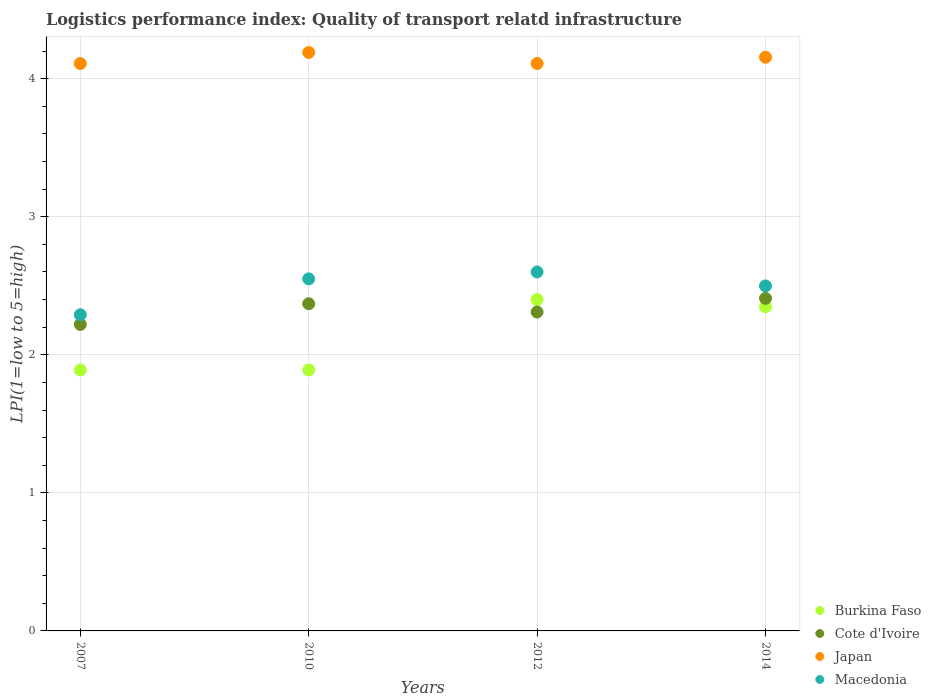How many different coloured dotlines are there?
Your answer should be compact. 4. What is the logistics performance index in Burkina Faso in 2010?
Make the answer very short. 1.89. Across all years, what is the maximum logistics performance index in Macedonia?
Provide a succinct answer. 2.6. Across all years, what is the minimum logistics performance index in Macedonia?
Your response must be concise. 2.29. What is the total logistics performance index in Macedonia in the graph?
Make the answer very short. 9.94. What is the difference between the logistics performance index in Macedonia in 2007 and that in 2014?
Your answer should be very brief. -0.21. What is the difference between the logistics performance index in Cote d'Ivoire in 2014 and the logistics performance index in Japan in 2010?
Offer a very short reply. -1.78. What is the average logistics performance index in Cote d'Ivoire per year?
Offer a terse response. 2.33. In the year 2010, what is the difference between the logistics performance index in Macedonia and logistics performance index in Burkina Faso?
Your answer should be very brief. 0.66. What is the ratio of the logistics performance index in Japan in 2007 to that in 2012?
Your answer should be compact. 1. What is the difference between the highest and the second highest logistics performance index in Macedonia?
Offer a terse response. 0.05. What is the difference between the highest and the lowest logistics performance index in Burkina Faso?
Give a very brief answer. 0.51. In how many years, is the logistics performance index in Japan greater than the average logistics performance index in Japan taken over all years?
Keep it short and to the point. 2. Does the logistics performance index in Cote d'Ivoire monotonically increase over the years?
Provide a succinct answer. No. Is the logistics performance index in Japan strictly less than the logistics performance index in Cote d'Ivoire over the years?
Your answer should be compact. No. What is the difference between two consecutive major ticks on the Y-axis?
Ensure brevity in your answer.  1. Does the graph contain grids?
Give a very brief answer. Yes. Where does the legend appear in the graph?
Offer a terse response. Bottom right. How many legend labels are there?
Offer a terse response. 4. How are the legend labels stacked?
Give a very brief answer. Vertical. What is the title of the graph?
Offer a very short reply. Logistics performance index: Quality of transport relatd infrastructure. What is the label or title of the X-axis?
Provide a short and direct response. Years. What is the label or title of the Y-axis?
Make the answer very short. LPI(1=low to 5=high). What is the LPI(1=low to 5=high) in Burkina Faso in 2007?
Offer a very short reply. 1.89. What is the LPI(1=low to 5=high) of Cote d'Ivoire in 2007?
Provide a succinct answer. 2.22. What is the LPI(1=low to 5=high) of Japan in 2007?
Keep it short and to the point. 4.11. What is the LPI(1=low to 5=high) of Macedonia in 2007?
Offer a terse response. 2.29. What is the LPI(1=low to 5=high) in Burkina Faso in 2010?
Your response must be concise. 1.89. What is the LPI(1=low to 5=high) in Cote d'Ivoire in 2010?
Provide a succinct answer. 2.37. What is the LPI(1=low to 5=high) in Japan in 2010?
Make the answer very short. 4.19. What is the LPI(1=low to 5=high) in Macedonia in 2010?
Offer a terse response. 2.55. What is the LPI(1=low to 5=high) of Burkina Faso in 2012?
Offer a terse response. 2.4. What is the LPI(1=low to 5=high) in Cote d'Ivoire in 2012?
Offer a very short reply. 2.31. What is the LPI(1=low to 5=high) in Japan in 2012?
Provide a short and direct response. 4.11. What is the LPI(1=low to 5=high) in Macedonia in 2012?
Your response must be concise. 2.6. What is the LPI(1=low to 5=high) in Burkina Faso in 2014?
Make the answer very short. 2.35. What is the LPI(1=low to 5=high) of Cote d'Ivoire in 2014?
Your response must be concise. 2.41. What is the LPI(1=low to 5=high) in Japan in 2014?
Your response must be concise. 4.16. What is the LPI(1=low to 5=high) of Macedonia in 2014?
Your response must be concise. 2.5. Across all years, what is the maximum LPI(1=low to 5=high) in Cote d'Ivoire?
Your response must be concise. 2.41. Across all years, what is the maximum LPI(1=low to 5=high) in Japan?
Ensure brevity in your answer.  4.19. Across all years, what is the maximum LPI(1=low to 5=high) in Macedonia?
Provide a short and direct response. 2.6. Across all years, what is the minimum LPI(1=low to 5=high) in Burkina Faso?
Give a very brief answer. 1.89. Across all years, what is the minimum LPI(1=low to 5=high) of Cote d'Ivoire?
Your answer should be very brief. 2.22. Across all years, what is the minimum LPI(1=low to 5=high) of Japan?
Provide a succinct answer. 4.11. Across all years, what is the minimum LPI(1=low to 5=high) of Macedonia?
Ensure brevity in your answer.  2.29. What is the total LPI(1=low to 5=high) in Burkina Faso in the graph?
Offer a terse response. 8.53. What is the total LPI(1=low to 5=high) of Cote d'Ivoire in the graph?
Give a very brief answer. 9.31. What is the total LPI(1=low to 5=high) of Japan in the graph?
Keep it short and to the point. 16.57. What is the total LPI(1=low to 5=high) in Macedonia in the graph?
Give a very brief answer. 9.94. What is the difference between the LPI(1=low to 5=high) in Burkina Faso in 2007 and that in 2010?
Keep it short and to the point. 0. What is the difference between the LPI(1=low to 5=high) in Cote d'Ivoire in 2007 and that in 2010?
Provide a short and direct response. -0.15. What is the difference between the LPI(1=low to 5=high) of Japan in 2007 and that in 2010?
Offer a very short reply. -0.08. What is the difference between the LPI(1=low to 5=high) of Macedonia in 2007 and that in 2010?
Provide a short and direct response. -0.26. What is the difference between the LPI(1=low to 5=high) of Burkina Faso in 2007 and that in 2012?
Keep it short and to the point. -0.51. What is the difference between the LPI(1=low to 5=high) of Cote d'Ivoire in 2007 and that in 2012?
Your response must be concise. -0.09. What is the difference between the LPI(1=low to 5=high) of Japan in 2007 and that in 2012?
Offer a very short reply. 0. What is the difference between the LPI(1=low to 5=high) in Macedonia in 2007 and that in 2012?
Provide a short and direct response. -0.31. What is the difference between the LPI(1=low to 5=high) of Burkina Faso in 2007 and that in 2014?
Your answer should be compact. -0.46. What is the difference between the LPI(1=low to 5=high) in Cote d'Ivoire in 2007 and that in 2014?
Provide a short and direct response. -0.19. What is the difference between the LPI(1=low to 5=high) of Japan in 2007 and that in 2014?
Provide a short and direct response. -0.05. What is the difference between the LPI(1=low to 5=high) of Macedonia in 2007 and that in 2014?
Your answer should be very brief. -0.21. What is the difference between the LPI(1=low to 5=high) in Burkina Faso in 2010 and that in 2012?
Ensure brevity in your answer.  -0.51. What is the difference between the LPI(1=low to 5=high) in Japan in 2010 and that in 2012?
Ensure brevity in your answer.  0.08. What is the difference between the LPI(1=low to 5=high) of Burkina Faso in 2010 and that in 2014?
Offer a terse response. -0.46. What is the difference between the LPI(1=low to 5=high) of Cote d'Ivoire in 2010 and that in 2014?
Offer a terse response. -0.04. What is the difference between the LPI(1=low to 5=high) in Japan in 2010 and that in 2014?
Your answer should be compact. 0.03. What is the difference between the LPI(1=low to 5=high) in Macedonia in 2010 and that in 2014?
Make the answer very short. 0.05. What is the difference between the LPI(1=low to 5=high) in Burkina Faso in 2012 and that in 2014?
Your answer should be very brief. 0.05. What is the difference between the LPI(1=low to 5=high) of Cote d'Ivoire in 2012 and that in 2014?
Give a very brief answer. -0.1. What is the difference between the LPI(1=low to 5=high) in Japan in 2012 and that in 2014?
Provide a short and direct response. -0.05. What is the difference between the LPI(1=low to 5=high) in Macedonia in 2012 and that in 2014?
Provide a short and direct response. 0.1. What is the difference between the LPI(1=low to 5=high) in Burkina Faso in 2007 and the LPI(1=low to 5=high) in Cote d'Ivoire in 2010?
Your answer should be very brief. -0.48. What is the difference between the LPI(1=low to 5=high) of Burkina Faso in 2007 and the LPI(1=low to 5=high) of Macedonia in 2010?
Your answer should be compact. -0.66. What is the difference between the LPI(1=low to 5=high) in Cote d'Ivoire in 2007 and the LPI(1=low to 5=high) in Japan in 2010?
Keep it short and to the point. -1.97. What is the difference between the LPI(1=low to 5=high) in Cote d'Ivoire in 2007 and the LPI(1=low to 5=high) in Macedonia in 2010?
Offer a terse response. -0.33. What is the difference between the LPI(1=low to 5=high) of Japan in 2007 and the LPI(1=low to 5=high) of Macedonia in 2010?
Provide a short and direct response. 1.56. What is the difference between the LPI(1=low to 5=high) in Burkina Faso in 2007 and the LPI(1=low to 5=high) in Cote d'Ivoire in 2012?
Keep it short and to the point. -0.42. What is the difference between the LPI(1=low to 5=high) of Burkina Faso in 2007 and the LPI(1=low to 5=high) of Japan in 2012?
Your answer should be compact. -2.22. What is the difference between the LPI(1=low to 5=high) of Burkina Faso in 2007 and the LPI(1=low to 5=high) of Macedonia in 2012?
Your answer should be compact. -0.71. What is the difference between the LPI(1=low to 5=high) of Cote d'Ivoire in 2007 and the LPI(1=low to 5=high) of Japan in 2012?
Keep it short and to the point. -1.89. What is the difference between the LPI(1=low to 5=high) of Cote d'Ivoire in 2007 and the LPI(1=low to 5=high) of Macedonia in 2012?
Your answer should be compact. -0.38. What is the difference between the LPI(1=low to 5=high) of Japan in 2007 and the LPI(1=low to 5=high) of Macedonia in 2012?
Give a very brief answer. 1.51. What is the difference between the LPI(1=low to 5=high) in Burkina Faso in 2007 and the LPI(1=low to 5=high) in Cote d'Ivoire in 2014?
Your response must be concise. -0.52. What is the difference between the LPI(1=low to 5=high) of Burkina Faso in 2007 and the LPI(1=low to 5=high) of Japan in 2014?
Give a very brief answer. -2.27. What is the difference between the LPI(1=low to 5=high) of Burkina Faso in 2007 and the LPI(1=low to 5=high) of Macedonia in 2014?
Your response must be concise. -0.61. What is the difference between the LPI(1=low to 5=high) of Cote d'Ivoire in 2007 and the LPI(1=low to 5=high) of Japan in 2014?
Your response must be concise. -1.94. What is the difference between the LPI(1=low to 5=high) in Cote d'Ivoire in 2007 and the LPI(1=low to 5=high) in Macedonia in 2014?
Your response must be concise. -0.28. What is the difference between the LPI(1=low to 5=high) in Japan in 2007 and the LPI(1=low to 5=high) in Macedonia in 2014?
Provide a succinct answer. 1.61. What is the difference between the LPI(1=low to 5=high) in Burkina Faso in 2010 and the LPI(1=low to 5=high) in Cote d'Ivoire in 2012?
Offer a terse response. -0.42. What is the difference between the LPI(1=low to 5=high) in Burkina Faso in 2010 and the LPI(1=low to 5=high) in Japan in 2012?
Offer a very short reply. -2.22. What is the difference between the LPI(1=low to 5=high) of Burkina Faso in 2010 and the LPI(1=low to 5=high) of Macedonia in 2012?
Give a very brief answer. -0.71. What is the difference between the LPI(1=low to 5=high) of Cote d'Ivoire in 2010 and the LPI(1=low to 5=high) of Japan in 2012?
Give a very brief answer. -1.74. What is the difference between the LPI(1=low to 5=high) of Cote d'Ivoire in 2010 and the LPI(1=low to 5=high) of Macedonia in 2012?
Provide a succinct answer. -0.23. What is the difference between the LPI(1=low to 5=high) of Japan in 2010 and the LPI(1=low to 5=high) of Macedonia in 2012?
Keep it short and to the point. 1.59. What is the difference between the LPI(1=low to 5=high) in Burkina Faso in 2010 and the LPI(1=low to 5=high) in Cote d'Ivoire in 2014?
Ensure brevity in your answer.  -0.52. What is the difference between the LPI(1=low to 5=high) in Burkina Faso in 2010 and the LPI(1=low to 5=high) in Japan in 2014?
Give a very brief answer. -2.27. What is the difference between the LPI(1=low to 5=high) in Burkina Faso in 2010 and the LPI(1=low to 5=high) in Macedonia in 2014?
Offer a very short reply. -0.61. What is the difference between the LPI(1=low to 5=high) in Cote d'Ivoire in 2010 and the LPI(1=low to 5=high) in Japan in 2014?
Provide a short and direct response. -1.79. What is the difference between the LPI(1=low to 5=high) in Cote d'Ivoire in 2010 and the LPI(1=low to 5=high) in Macedonia in 2014?
Provide a succinct answer. -0.13. What is the difference between the LPI(1=low to 5=high) of Japan in 2010 and the LPI(1=low to 5=high) of Macedonia in 2014?
Provide a short and direct response. 1.69. What is the difference between the LPI(1=low to 5=high) of Burkina Faso in 2012 and the LPI(1=low to 5=high) of Cote d'Ivoire in 2014?
Your answer should be compact. -0.01. What is the difference between the LPI(1=low to 5=high) in Burkina Faso in 2012 and the LPI(1=low to 5=high) in Japan in 2014?
Your answer should be compact. -1.76. What is the difference between the LPI(1=low to 5=high) in Burkina Faso in 2012 and the LPI(1=low to 5=high) in Macedonia in 2014?
Your response must be concise. -0.1. What is the difference between the LPI(1=low to 5=high) of Cote d'Ivoire in 2012 and the LPI(1=low to 5=high) of Japan in 2014?
Provide a short and direct response. -1.85. What is the difference between the LPI(1=low to 5=high) of Cote d'Ivoire in 2012 and the LPI(1=low to 5=high) of Macedonia in 2014?
Offer a very short reply. -0.19. What is the difference between the LPI(1=low to 5=high) in Japan in 2012 and the LPI(1=low to 5=high) in Macedonia in 2014?
Give a very brief answer. 1.61. What is the average LPI(1=low to 5=high) of Burkina Faso per year?
Your response must be concise. 2.13. What is the average LPI(1=low to 5=high) of Cote d'Ivoire per year?
Keep it short and to the point. 2.33. What is the average LPI(1=low to 5=high) of Japan per year?
Offer a very short reply. 4.14. What is the average LPI(1=low to 5=high) in Macedonia per year?
Ensure brevity in your answer.  2.48. In the year 2007, what is the difference between the LPI(1=low to 5=high) in Burkina Faso and LPI(1=low to 5=high) in Cote d'Ivoire?
Your answer should be compact. -0.33. In the year 2007, what is the difference between the LPI(1=low to 5=high) of Burkina Faso and LPI(1=low to 5=high) of Japan?
Make the answer very short. -2.22. In the year 2007, what is the difference between the LPI(1=low to 5=high) of Burkina Faso and LPI(1=low to 5=high) of Macedonia?
Offer a terse response. -0.4. In the year 2007, what is the difference between the LPI(1=low to 5=high) in Cote d'Ivoire and LPI(1=low to 5=high) in Japan?
Offer a very short reply. -1.89. In the year 2007, what is the difference between the LPI(1=low to 5=high) in Cote d'Ivoire and LPI(1=low to 5=high) in Macedonia?
Your answer should be compact. -0.07. In the year 2007, what is the difference between the LPI(1=low to 5=high) of Japan and LPI(1=low to 5=high) of Macedonia?
Offer a very short reply. 1.82. In the year 2010, what is the difference between the LPI(1=low to 5=high) in Burkina Faso and LPI(1=low to 5=high) in Cote d'Ivoire?
Your answer should be very brief. -0.48. In the year 2010, what is the difference between the LPI(1=low to 5=high) of Burkina Faso and LPI(1=low to 5=high) of Japan?
Give a very brief answer. -2.3. In the year 2010, what is the difference between the LPI(1=low to 5=high) in Burkina Faso and LPI(1=low to 5=high) in Macedonia?
Offer a very short reply. -0.66. In the year 2010, what is the difference between the LPI(1=low to 5=high) of Cote d'Ivoire and LPI(1=low to 5=high) of Japan?
Give a very brief answer. -1.82. In the year 2010, what is the difference between the LPI(1=low to 5=high) of Cote d'Ivoire and LPI(1=low to 5=high) of Macedonia?
Provide a short and direct response. -0.18. In the year 2010, what is the difference between the LPI(1=low to 5=high) in Japan and LPI(1=low to 5=high) in Macedonia?
Your response must be concise. 1.64. In the year 2012, what is the difference between the LPI(1=low to 5=high) in Burkina Faso and LPI(1=low to 5=high) in Cote d'Ivoire?
Offer a terse response. 0.09. In the year 2012, what is the difference between the LPI(1=low to 5=high) of Burkina Faso and LPI(1=low to 5=high) of Japan?
Ensure brevity in your answer.  -1.71. In the year 2012, what is the difference between the LPI(1=low to 5=high) of Burkina Faso and LPI(1=low to 5=high) of Macedonia?
Make the answer very short. -0.2. In the year 2012, what is the difference between the LPI(1=low to 5=high) of Cote d'Ivoire and LPI(1=low to 5=high) of Japan?
Provide a succinct answer. -1.8. In the year 2012, what is the difference between the LPI(1=low to 5=high) of Cote d'Ivoire and LPI(1=low to 5=high) of Macedonia?
Give a very brief answer. -0.29. In the year 2012, what is the difference between the LPI(1=low to 5=high) of Japan and LPI(1=low to 5=high) of Macedonia?
Your answer should be compact. 1.51. In the year 2014, what is the difference between the LPI(1=low to 5=high) in Burkina Faso and LPI(1=low to 5=high) in Cote d'Ivoire?
Your response must be concise. -0.06. In the year 2014, what is the difference between the LPI(1=low to 5=high) of Burkina Faso and LPI(1=low to 5=high) of Japan?
Provide a succinct answer. -1.81. In the year 2014, what is the difference between the LPI(1=low to 5=high) of Burkina Faso and LPI(1=low to 5=high) of Macedonia?
Offer a terse response. -0.15. In the year 2014, what is the difference between the LPI(1=low to 5=high) of Cote d'Ivoire and LPI(1=low to 5=high) of Japan?
Offer a terse response. -1.75. In the year 2014, what is the difference between the LPI(1=low to 5=high) of Cote d'Ivoire and LPI(1=low to 5=high) of Macedonia?
Your answer should be compact. -0.09. In the year 2014, what is the difference between the LPI(1=low to 5=high) of Japan and LPI(1=low to 5=high) of Macedonia?
Your answer should be very brief. 1.66. What is the ratio of the LPI(1=low to 5=high) of Cote d'Ivoire in 2007 to that in 2010?
Your answer should be very brief. 0.94. What is the ratio of the LPI(1=low to 5=high) of Japan in 2007 to that in 2010?
Offer a very short reply. 0.98. What is the ratio of the LPI(1=low to 5=high) of Macedonia in 2007 to that in 2010?
Make the answer very short. 0.9. What is the ratio of the LPI(1=low to 5=high) of Burkina Faso in 2007 to that in 2012?
Provide a succinct answer. 0.79. What is the ratio of the LPI(1=low to 5=high) of Japan in 2007 to that in 2012?
Keep it short and to the point. 1. What is the ratio of the LPI(1=low to 5=high) in Macedonia in 2007 to that in 2012?
Give a very brief answer. 0.88. What is the ratio of the LPI(1=low to 5=high) of Burkina Faso in 2007 to that in 2014?
Offer a very short reply. 0.8. What is the ratio of the LPI(1=low to 5=high) of Cote d'Ivoire in 2007 to that in 2014?
Your answer should be compact. 0.92. What is the ratio of the LPI(1=low to 5=high) of Japan in 2007 to that in 2014?
Your answer should be very brief. 0.99. What is the ratio of the LPI(1=low to 5=high) of Macedonia in 2007 to that in 2014?
Provide a succinct answer. 0.92. What is the ratio of the LPI(1=low to 5=high) in Burkina Faso in 2010 to that in 2012?
Your answer should be compact. 0.79. What is the ratio of the LPI(1=low to 5=high) in Japan in 2010 to that in 2012?
Give a very brief answer. 1.02. What is the ratio of the LPI(1=low to 5=high) in Macedonia in 2010 to that in 2012?
Offer a terse response. 0.98. What is the ratio of the LPI(1=low to 5=high) in Burkina Faso in 2010 to that in 2014?
Provide a succinct answer. 0.8. What is the ratio of the LPI(1=low to 5=high) in Cote d'Ivoire in 2010 to that in 2014?
Provide a short and direct response. 0.98. What is the ratio of the LPI(1=low to 5=high) in Japan in 2010 to that in 2014?
Your response must be concise. 1.01. What is the ratio of the LPI(1=low to 5=high) of Macedonia in 2010 to that in 2014?
Your answer should be very brief. 1.02. What is the ratio of the LPI(1=low to 5=high) in Burkina Faso in 2012 to that in 2014?
Offer a terse response. 1.02. What is the ratio of the LPI(1=low to 5=high) in Macedonia in 2012 to that in 2014?
Make the answer very short. 1.04. What is the difference between the highest and the second highest LPI(1=low to 5=high) in Burkina Faso?
Keep it short and to the point. 0.05. What is the difference between the highest and the second highest LPI(1=low to 5=high) of Cote d'Ivoire?
Your response must be concise. 0.04. What is the difference between the highest and the second highest LPI(1=low to 5=high) in Japan?
Make the answer very short. 0.03. What is the difference between the highest and the lowest LPI(1=low to 5=high) of Burkina Faso?
Provide a succinct answer. 0.51. What is the difference between the highest and the lowest LPI(1=low to 5=high) in Cote d'Ivoire?
Your answer should be compact. 0.19. What is the difference between the highest and the lowest LPI(1=low to 5=high) in Japan?
Provide a short and direct response. 0.08. What is the difference between the highest and the lowest LPI(1=low to 5=high) of Macedonia?
Offer a very short reply. 0.31. 